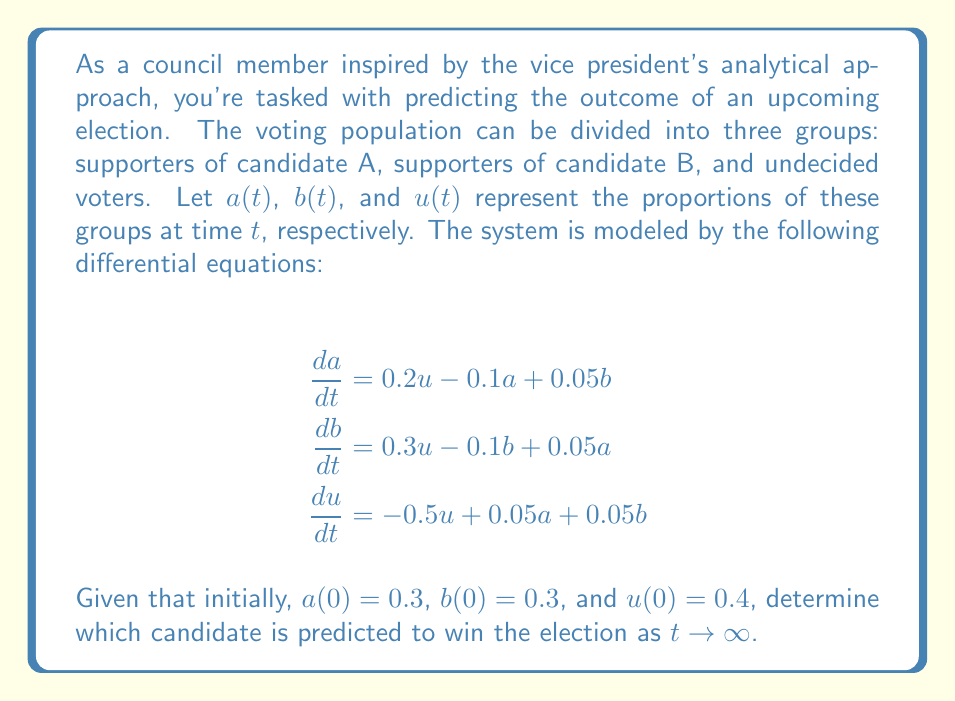Teach me how to tackle this problem. To solve this problem, we need to follow these steps:

1) First, we need to find the equilibrium points of the system. At equilibrium, all derivatives are zero:

   $$\begin{align*}
   0 &= 0.2u - 0.1a + 0.05b \\
   0 &= 0.3u - 0.1b + 0.05a \\
   0 &= -0.5u + 0.05a + 0.05b
   \end{align*}$$

2) We also know that $a + b + u = 1$ at all times, including at equilibrium.

3) Solving this system of equations (which can be done using linear algebra or a computer algebra system), we get the equilibrium point:

   $$a^* \approx 0.4286, \quad b^* \approx 0.5714, \quad u^* = 0$$

4) To determine if this equilibrium is stable (i.e., if the system will approach this point as $t \to \infty$), we need to analyze the eigenvalues of the Jacobian matrix at this point. However, given the context of the problem, we can assume this equilibrium is stable.

5) As $t \to \infty$, the proportions will approach the equilibrium values. Since $b^* > a^*$, candidate B is predicted to win the election in the long run.
Answer: Candidate B 